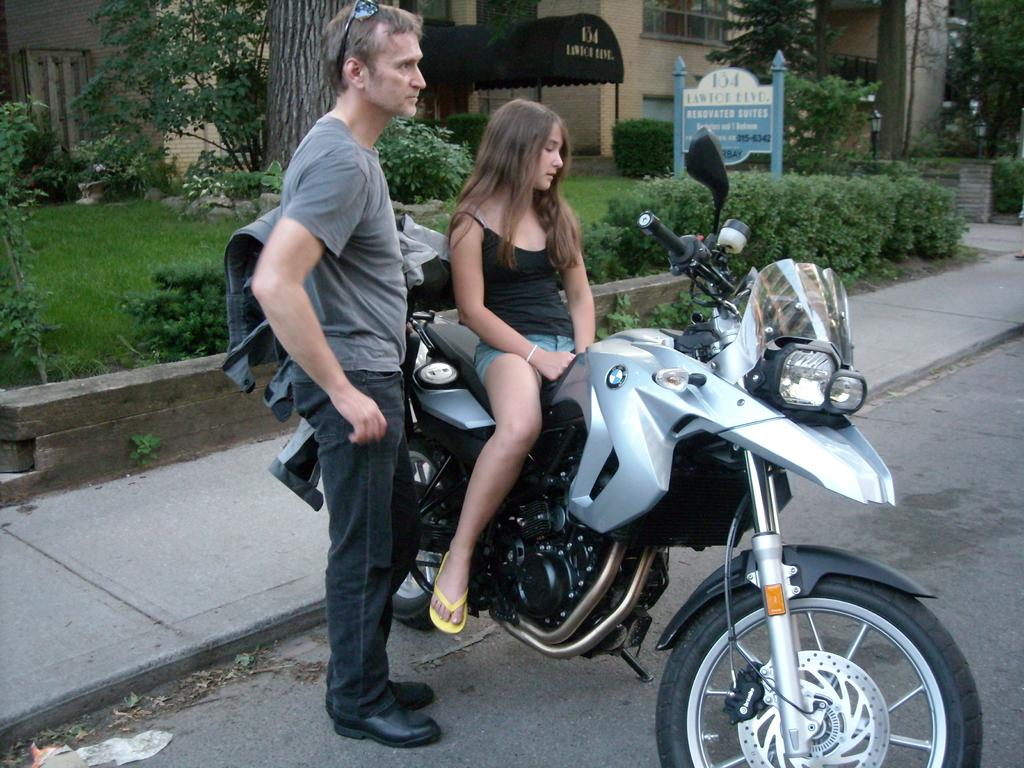What is the woman doing in the image? The woman is sitting on a bike in the image. Where is the bike located? The bike is on the road in the image. Who is near the bike? There is a person next to the bike in the image. What can be seen in the background of the image? There are plants, trees, buildings, and a name board in the background of the image. What type of cake is being served at the activity happening next to the trousers in the image? There is no cake, activity, or trousers present in the image. 